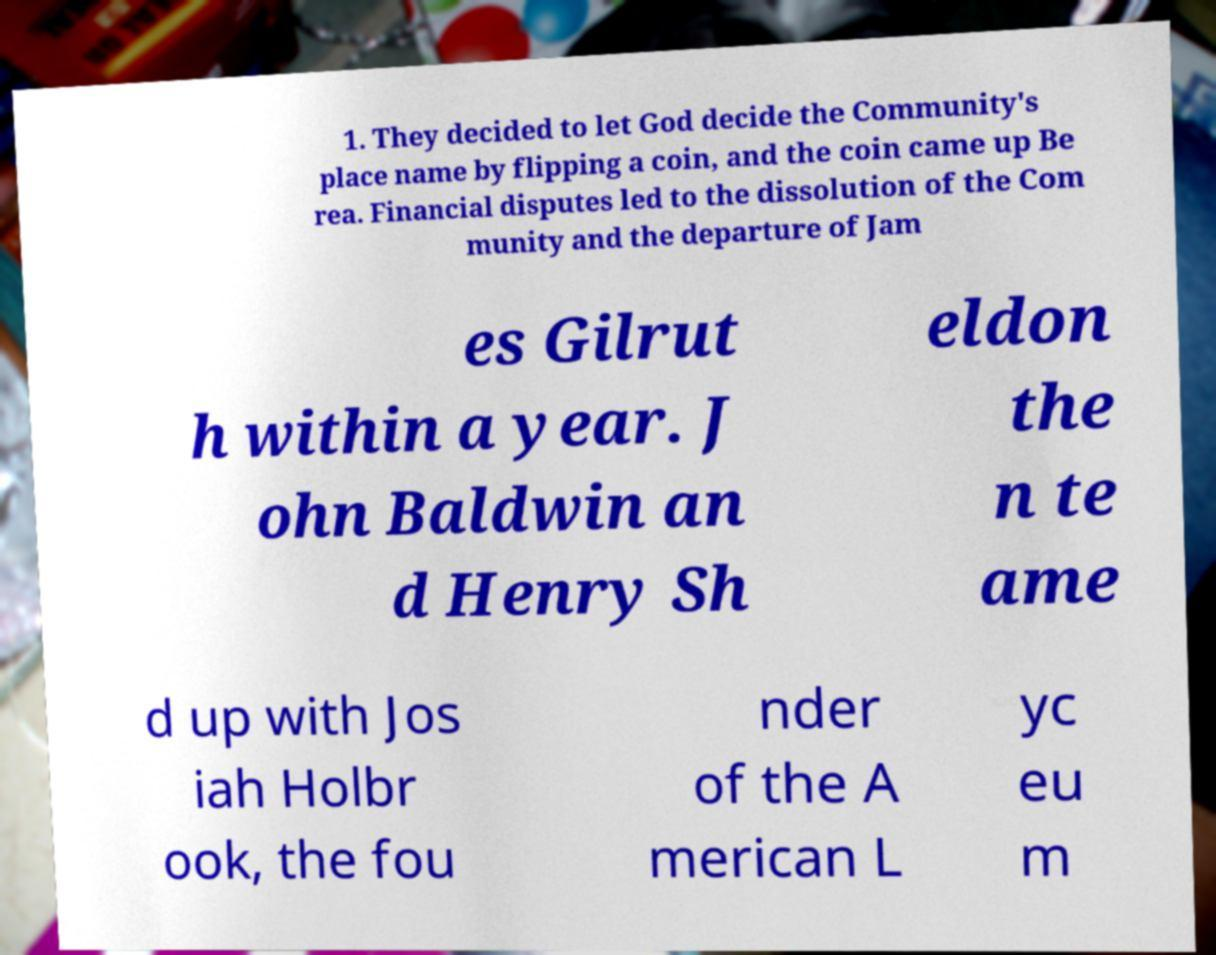Please identify and transcribe the text found in this image. 1. They decided to let God decide the Community's place name by flipping a coin, and the coin came up Be rea. Financial disputes led to the dissolution of the Com munity and the departure of Jam es Gilrut h within a year. J ohn Baldwin an d Henry Sh eldon the n te ame d up with Jos iah Holbr ook, the fou nder of the A merican L yc eu m 